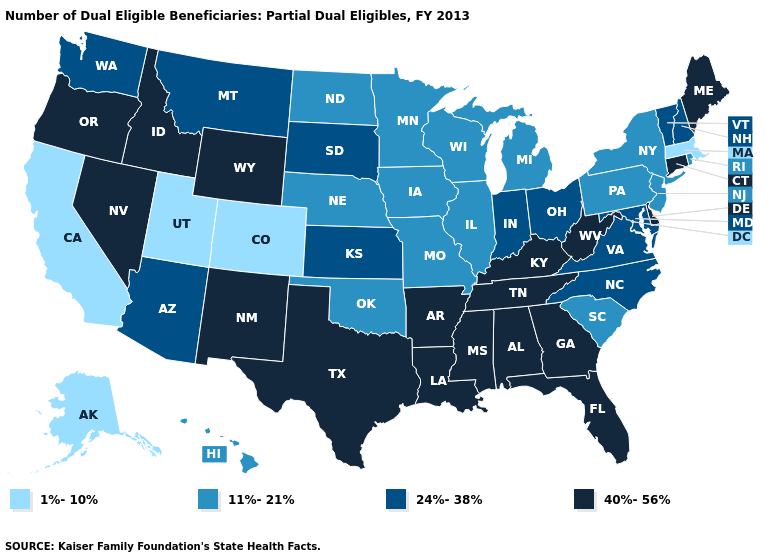What is the lowest value in states that border Nevada?
Be succinct. 1%-10%. What is the value of California?
Answer briefly. 1%-10%. What is the value of Delaware?
Concise answer only. 40%-56%. Does Maine have the highest value in the Northeast?
Keep it brief. Yes. What is the value of West Virginia?
Answer briefly. 40%-56%. Which states have the highest value in the USA?
Quick response, please. Alabama, Arkansas, Connecticut, Delaware, Florida, Georgia, Idaho, Kentucky, Louisiana, Maine, Mississippi, Nevada, New Mexico, Oregon, Tennessee, Texas, West Virginia, Wyoming. Does Massachusetts have the lowest value in the USA?
Give a very brief answer. Yes. Does the map have missing data?
Keep it brief. No. Among the states that border New Jersey , which have the lowest value?
Write a very short answer. New York, Pennsylvania. Name the states that have a value in the range 1%-10%?
Quick response, please. Alaska, California, Colorado, Massachusetts, Utah. What is the value of Kentucky?
Concise answer only. 40%-56%. What is the highest value in the South ?
Concise answer only. 40%-56%. Name the states that have a value in the range 24%-38%?
Give a very brief answer. Arizona, Indiana, Kansas, Maryland, Montana, New Hampshire, North Carolina, Ohio, South Dakota, Vermont, Virginia, Washington. What is the value of Montana?
Write a very short answer. 24%-38%. Name the states that have a value in the range 11%-21%?
Answer briefly. Hawaii, Illinois, Iowa, Michigan, Minnesota, Missouri, Nebraska, New Jersey, New York, North Dakota, Oklahoma, Pennsylvania, Rhode Island, South Carolina, Wisconsin. 